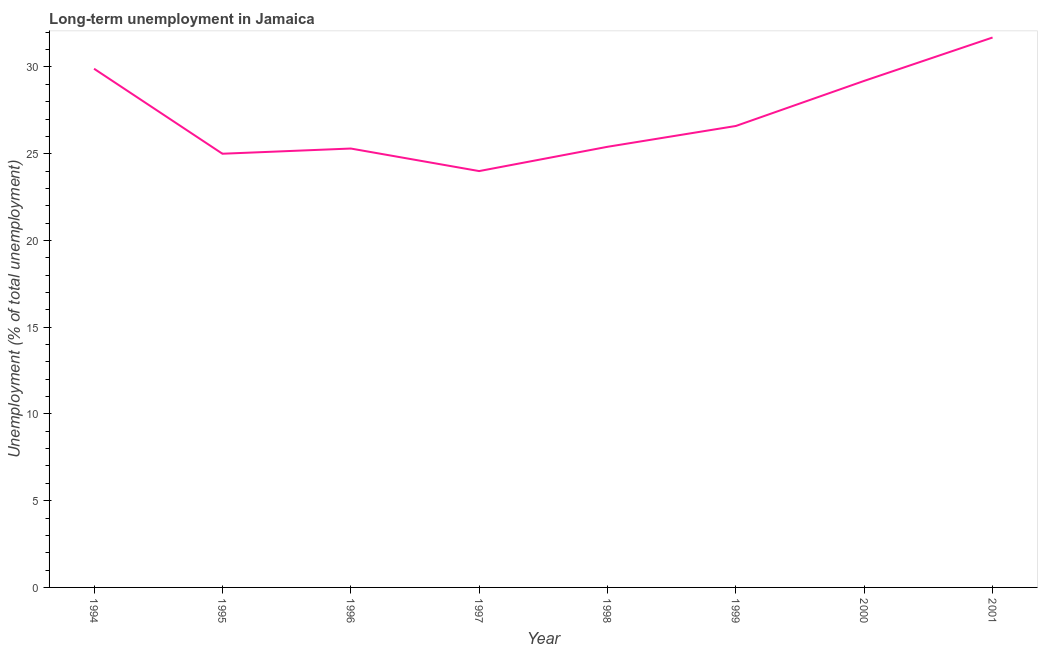What is the long-term unemployment in 1996?
Give a very brief answer. 25.3. Across all years, what is the maximum long-term unemployment?
Your answer should be very brief. 31.7. Across all years, what is the minimum long-term unemployment?
Your answer should be compact. 24. In which year was the long-term unemployment maximum?
Make the answer very short. 2001. What is the sum of the long-term unemployment?
Ensure brevity in your answer.  217.1. What is the difference between the long-term unemployment in 1996 and 2000?
Provide a short and direct response. -3.9. What is the average long-term unemployment per year?
Provide a short and direct response. 27.14. What is the median long-term unemployment?
Offer a very short reply. 26. In how many years, is the long-term unemployment greater than 17 %?
Give a very brief answer. 8. Do a majority of the years between 1996 and 1997 (inclusive) have long-term unemployment greater than 31 %?
Provide a short and direct response. No. What is the ratio of the long-term unemployment in 1998 to that in 1999?
Keep it short and to the point. 0.95. What is the difference between the highest and the second highest long-term unemployment?
Provide a succinct answer. 1.8. What is the difference between the highest and the lowest long-term unemployment?
Give a very brief answer. 7.7. Does the long-term unemployment monotonically increase over the years?
Make the answer very short. No. How many lines are there?
Your answer should be very brief. 1. How many years are there in the graph?
Your answer should be very brief. 8. What is the difference between two consecutive major ticks on the Y-axis?
Ensure brevity in your answer.  5. Does the graph contain any zero values?
Your answer should be very brief. No. Does the graph contain grids?
Your answer should be compact. No. What is the title of the graph?
Keep it short and to the point. Long-term unemployment in Jamaica. What is the label or title of the X-axis?
Your response must be concise. Year. What is the label or title of the Y-axis?
Provide a short and direct response. Unemployment (% of total unemployment). What is the Unemployment (% of total unemployment) in 1994?
Give a very brief answer. 29.9. What is the Unemployment (% of total unemployment) in 1995?
Keep it short and to the point. 25. What is the Unemployment (% of total unemployment) in 1996?
Give a very brief answer. 25.3. What is the Unemployment (% of total unemployment) of 1998?
Your answer should be compact. 25.4. What is the Unemployment (% of total unemployment) in 1999?
Offer a terse response. 26.6. What is the Unemployment (% of total unemployment) of 2000?
Your answer should be very brief. 29.2. What is the Unemployment (% of total unemployment) in 2001?
Provide a succinct answer. 31.7. What is the difference between the Unemployment (% of total unemployment) in 1994 and 1995?
Make the answer very short. 4.9. What is the difference between the Unemployment (% of total unemployment) in 1994 and 1997?
Your answer should be compact. 5.9. What is the difference between the Unemployment (% of total unemployment) in 1994 and 1998?
Your answer should be compact. 4.5. What is the difference between the Unemployment (% of total unemployment) in 1995 and 1997?
Make the answer very short. 1. What is the difference between the Unemployment (% of total unemployment) in 1995 and 2000?
Provide a short and direct response. -4.2. What is the difference between the Unemployment (% of total unemployment) in 1996 and 1997?
Keep it short and to the point. 1.3. What is the difference between the Unemployment (% of total unemployment) in 1996 and 1998?
Your answer should be compact. -0.1. What is the difference between the Unemployment (% of total unemployment) in 1996 and 2001?
Give a very brief answer. -6.4. What is the difference between the Unemployment (% of total unemployment) in 1997 and 1998?
Provide a succinct answer. -1.4. What is the difference between the Unemployment (% of total unemployment) in 1997 and 2000?
Keep it short and to the point. -5.2. What is the difference between the Unemployment (% of total unemployment) in 1997 and 2001?
Your answer should be very brief. -7.7. What is the difference between the Unemployment (% of total unemployment) in 1998 and 1999?
Your answer should be compact. -1.2. What is the difference between the Unemployment (% of total unemployment) in 1998 and 2001?
Your response must be concise. -6.3. What is the ratio of the Unemployment (% of total unemployment) in 1994 to that in 1995?
Provide a succinct answer. 1.2. What is the ratio of the Unemployment (% of total unemployment) in 1994 to that in 1996?
Make the answer very short. 1.18. What is the ratio of the Unemployment (% of total unemployment) in 1994 to that in 1997?
Your answer should be compact. 1.25. What is the ratio of the Unemployment (% of total unemployment) in 1994 to that in 1998?
Provide a short and direct response. 1.18. What is the ratio of the Unemployment (% of total unemployment) in 1994 to that in 1999?
Provide a succinct answer. 1.12. What is the ratio of the Unemployment (% of total unemployment) in 1994 to that in 2001?
Your answer should be compact. 0.94. What is the ratio of the Unemployment (% of total unemployment) in 1995 to that in 1996?
Provide a succinct answer. 0.99. What is the ratio of the Unemployment (% of total unemployment) in 1995 to that in 1997?
Provide a short and direct response. 1.04. What is the ratio of the Unemployment (% of total unemployment) in 1995 to that in 1999?
Ensure brevity in your answer.  0.94. What is the ratio of the Unemployment (% of total unemployment) in 1995 to that in 2000?
Offer a terse response. 0.86. What is the ratio of the Unemployment (% of total unemployment) in 1995 to that in 2001?
Offer a terse response. 0.79. What is the ratio of the Unemployment (% of total unemployment) in 1996 to that in 1997?
Keep it short and to the point. 1.05. What is the ratio of the Unemployment (% of total unemployment) in 1996 to that in 1998?
Your response must be concise. 1. What is the ratio of the Unemployment (% of total unemployment) in 1996 to that in 1999?
Make the answer very short. 0.95. What is the ratio of the Unemployment (% of total unemployment) in 1996 to that in 2000?
Your response must be concise. 0.87. What is the ratio of the Unemployment (% of total unemployment) in 1996 to that in 2001?
Offer a terse response. 0.8. What is the ratio of the Unemployment (% of total unemployment) in 1997 to that in 1998?
Make the answer very short. 0.94. What is the ratio of the Unemployment (% of total unemployment) in 1997 to that in 1999?
Give a very brief answer. 0.9. What is the ratio of the Unemployment (% of total unemployment) in 1997 to that in 2000?
Make the answer very short. 0.82. What is the ratio of the Unemployment (% of total unemployment) in 1997 to that in 2001?
Your answer should be compact. 0.76. What is the ratio of the Unemployment (% of total unemployment) in 1998 to that in 1999?
Keep it short and to the point. 0.95. What is the ratio of the Unemployment (% of total unemployment) in 1998 to that in 2000?
Provide a short and direct response. 0.87. What is the ratio of the Unemployment (% of total unemployment) in 1998 to that in 2001?
Offer a very short reply. 0.8. What is the ratio of the Unemployment (% of total unemployment) in 1999 to that in 2000?
Your answer should be compact. 0.91. What is the ratio of the Unemployment (% of total unemployment) in 1999 to that in 2001?
Keep it short and to the point. 0.84. What is the ratio of the Unemployment (% of total unemployment) in 2000 to that in 2001?
Ensure brevity in your answer.  0.92. 